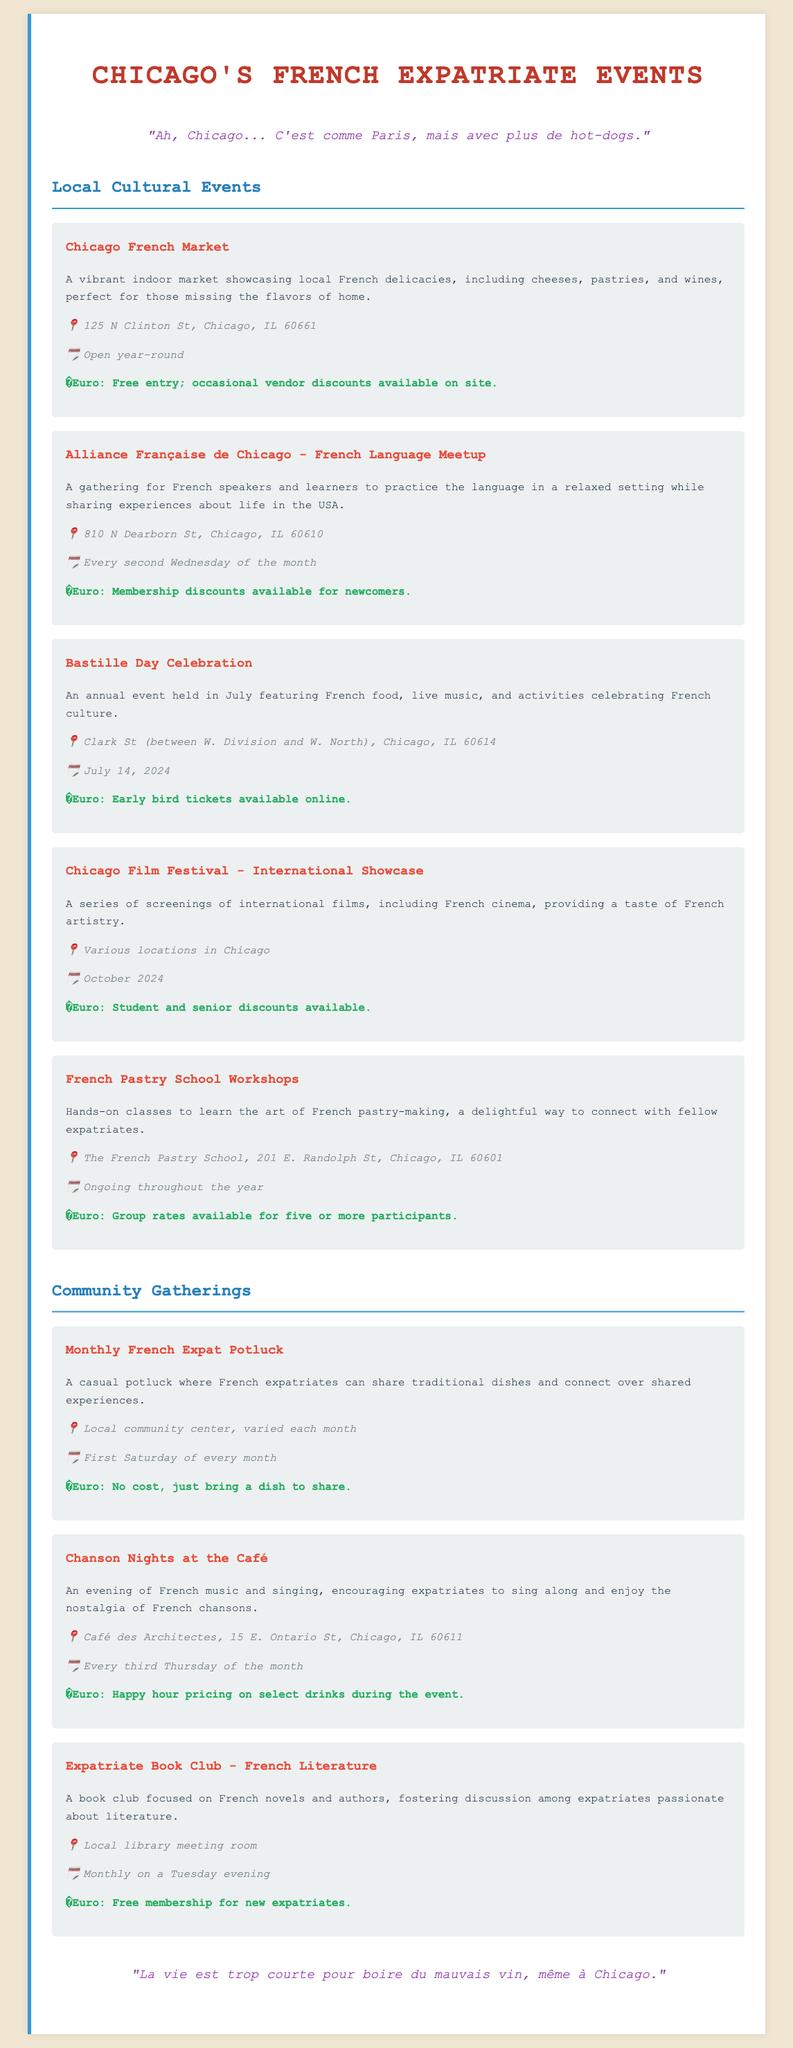What is the location of the Chicago French Market? The Chicago French Market is located at 125 N Clinton St, Chicago, IL 60661.
Answer: 125 N Clinton St, Chicago, IL 60661 When is the Bastille Day Celebration? The Bastille Day Celebration is held on July 14, 2024.
Answer: July 14, 2024 What type of discounts are available at the Chicago Film Festival? The Chicago Film Festival offers student and senior discounts.
Answer: Student and senior discounts How often does the French Language Meetup occur? The French Language Meetup occurs every second Wednesday of the month.
Answer: Every second Wednesday of the month What is the main purpose of the Monthly French Expat Potluck? The Monthly French Expat Potluck allows French expatriates to share traditional dishes and connect.
Answer: Share traditional dishes and connect Which event features happy hour pricing on drinks? Chanson Nights at the Café features happy hour pricing on select drinks during the event.
Answer: Chanson Nights at the Café What community activity meets monthly on a Tuesday evening? The Expatriate Book Club - French Literature meets monthly on a Tuesday evening.
Answer: Expatriate Book Club - French Literature What is the title of the quote featured in the document? The quote in the document highlights a humorous take on life in Chicago, resembling Paris but with hot-dogs.
Answer: "Ah, Chicago... C'est comme Paris, mais avec plus de hot-dogs." 